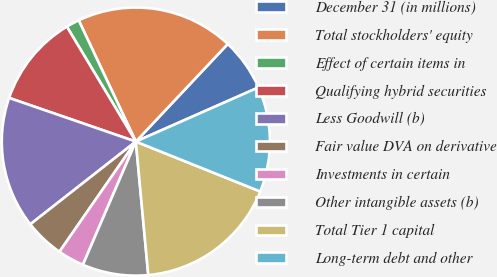Convert chart. <chart><loc_0><loc_0><loc_500><loc_500><pie_chart><fcel>December 31 (in millions)<fcel>Total stockholders' equity<fcel>Effect of certain items in<fcel>Qualifying hybrid securities<fcel>Less Goodwill (b)<fcel>Fair value DVA on derivative<fcel>Investments in certain<fcel>Other intangible assets (b)<fcel>Total Tier 1 capital<fcel>Long-term debt and other<nl><fcel>6.36%<fcel>19.03%<fcel>1.6%<fcel>11.11%<fcel>15.86%<fcel>4.77%<fcel>3.19%<fcel>7.94%<fcel>17.45%<fcel>12.69%<nl></chart> 